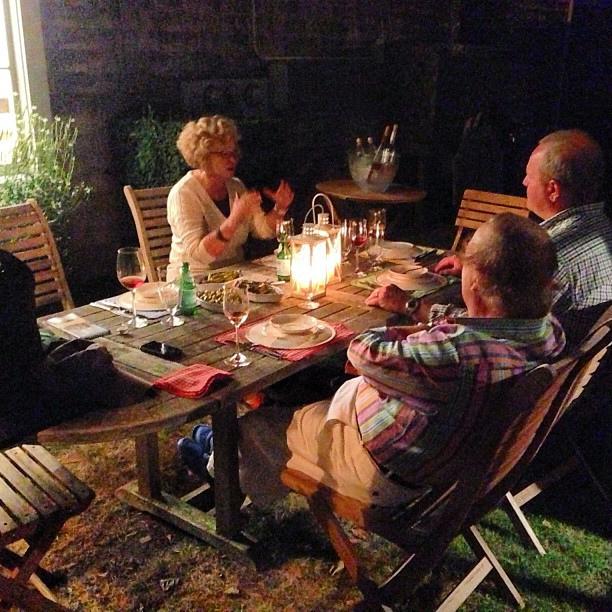How many red wines glasses are on the table?
Be succinct. 4. Are they planning to do something bad?
Short answer required. No. How many men at the table?
Concise answer only. 2. 